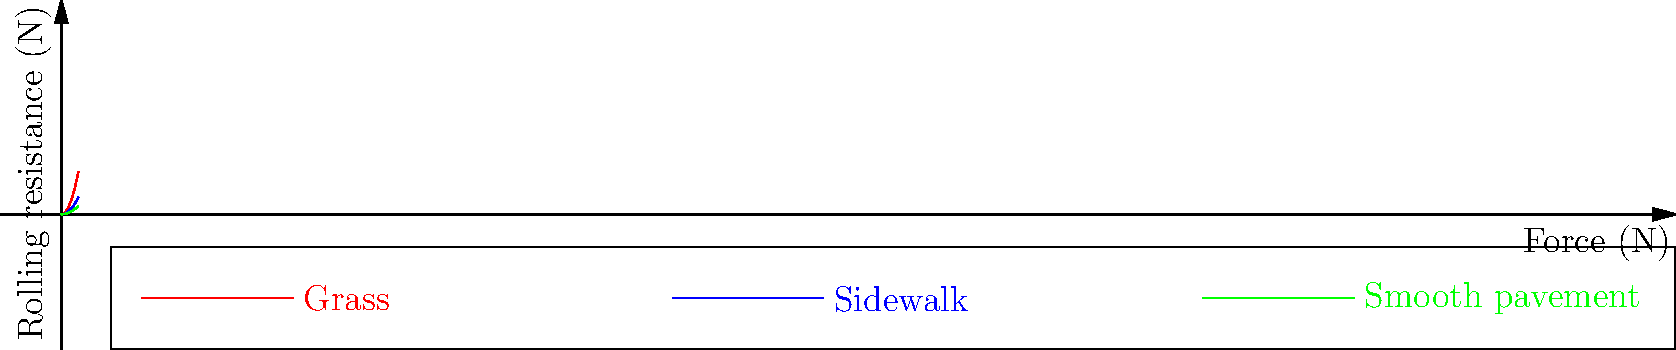When pushing a stroller, you notice it requires different amounts of effort on various surfaces. The graph shows the relationship between the force applied and the rolling resistance for different surfaces. Which surface would require the least effort to push the stroller, and why? To determine which surface requires the least effort to push the stroller, we need to analyze the rolling resistance for each surface:

1. The rolling resistance is represented by the y-axis of the graph.
2. For a given applied force (x-axis), the surface with the lowest y-value will have the least rolling resistance.
3. Looking at the graph:
   - The red line (grass) has the steepest slope, indicating the highest rolling resistance.
   - The blue line (sidewalk) has a moderate slope, indicating medium rolling resistance.
   - The green line (smooth pavement) has the shallowest slope, indicating the lowest rolling resistance.
4. The relationship between force and rolling resistance is quadratic ($$y = ax^2$$), where 'a' is smallest for smooth pavement.
5. A smaller 'a' value means less force is required to overcome rolling resistance.

Therefore, smooth pavement would require the least effort to push the stroller because it has the lowest rolling resistance for any given applied force.
Answer: Smooth pavement, due to lowest rolling resistance. 